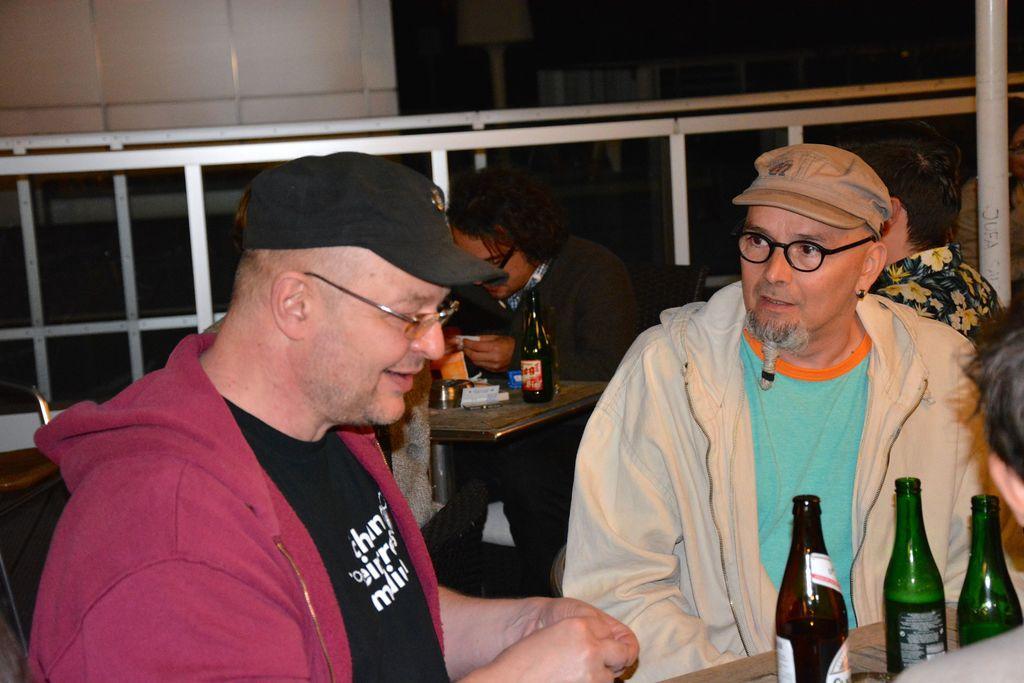Describe this image in one or two sentences. There are group of persons sitting on the chair. This is a table where a beer bottle and some objects are placed. This looks like a white pole. At background I can see a white barre gate. 